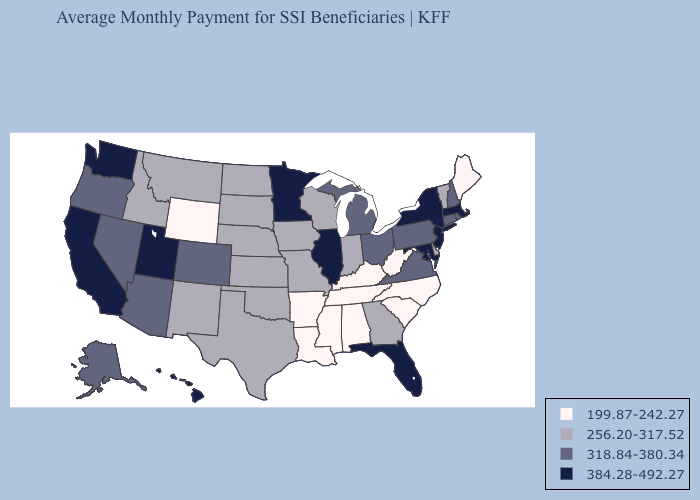Among the states that border Montana , does South Dakota have the lowest value?
Answer briefly. No. Name the states that have a value in the range 384.28-492.27?
Short answer required. California, Florida, Hawaii, Illinois, Maryland, Massachusetts, Minnesota, New Jersey, New York, Utah, Washington. What is the value of South Dakota?
Short answer required. 256.20-317.52. Among the states that border Indiana , does Kentucky have the highest value?
Give a very brief answer. No. Name the states that have a value in the range 318.84-380.34?
Write a very short answer. Alaska, Arizona, Colorado, Connecticut, Michigan, Nevada, New Hampshire, Ohio, Oregon, Pennsylvania, Rhode Island, Virginia. Is the legend a continuous bar?
Quick response, please. No. What is the value of Arkansas?
Write a very short answer. 199.87-242.27. Does the first symbol in the legend represent the smallest category?
Short answer required. Yes. Among the states that border Texas , which have the lowest value?
Quick response, please. Arkansas, Louisiana. What is the lowest value in the South?
Be succinct. 199.87-242.27. What is the value of Utah?
Quick response, please. 384.28-492.27. Among the states that border Oregon , which have the highest value?
Short answer required. California, Washington. Does the map have missing data?
Short answer required. No. Name the states that have a value in the range 256.20-317.52?
Quick response, please. Delaware, Georgia, Idaho, Indiana, Iowa, Kansas, Missouri, Montana, Nebraska, New Mexico, North Dakota, Oklahoma, South Dakota, Texas, Vermont, Wisconsin. Does North Dakota have the highest value in the MidWest?
Give a very brief answer. No. 